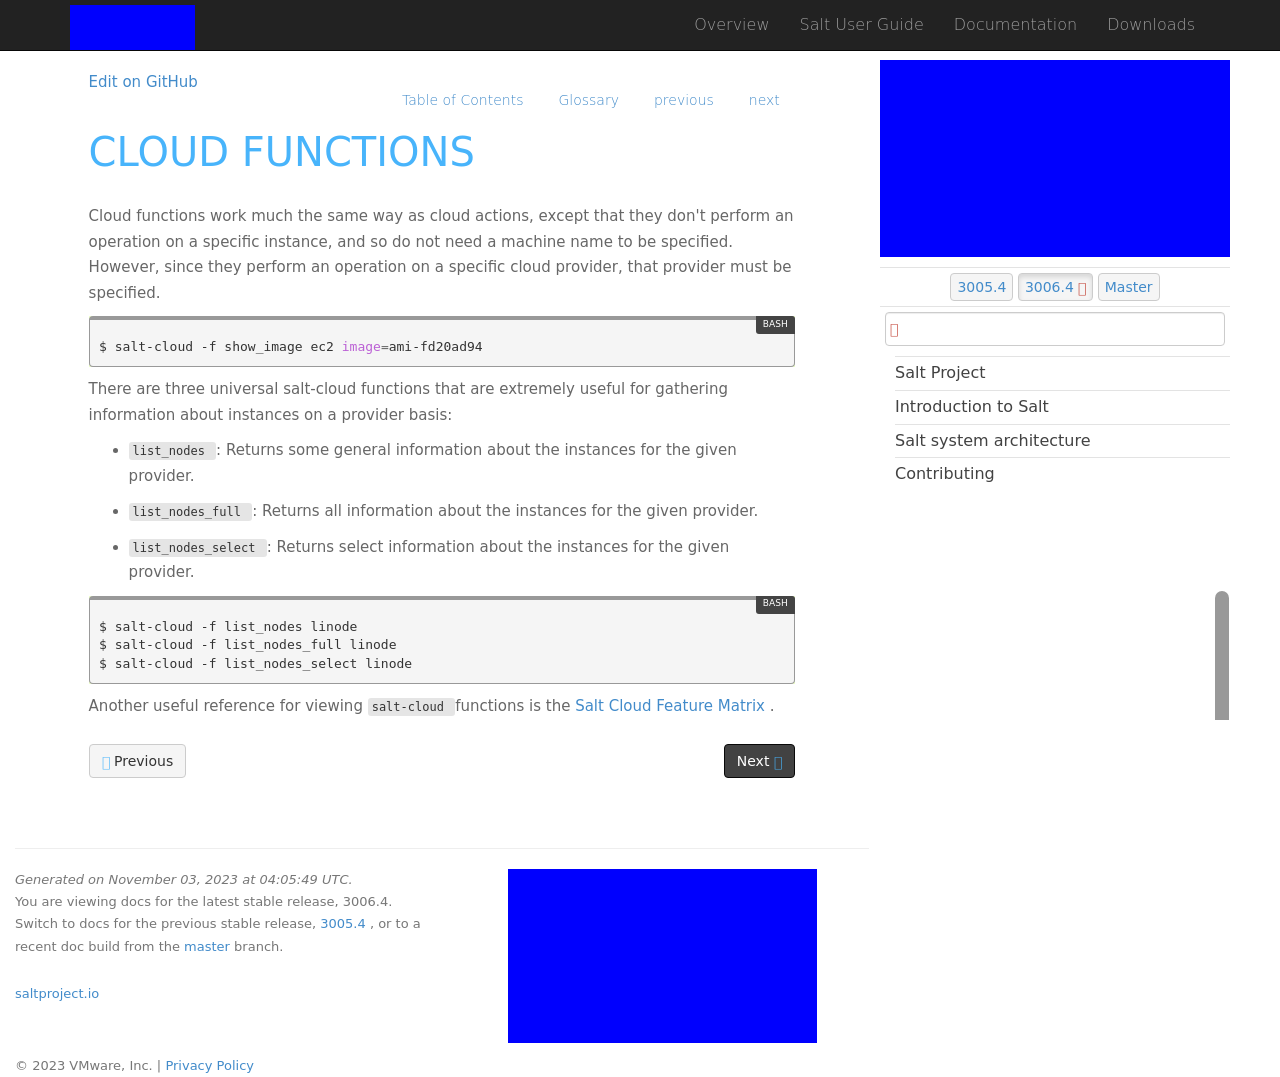What programming concepts can be inferred from the visible code snippets in the image? The code snippets visible in the image suggest use of commands related to cloud-based functionalities, particularly managing and interacting with cloud instances using a command line tool. The snippets using 'salt-cloud' indicate that the website might be related to cloud management or infrastructure services that utilize SALT, a configuration management and orchestration tool. 